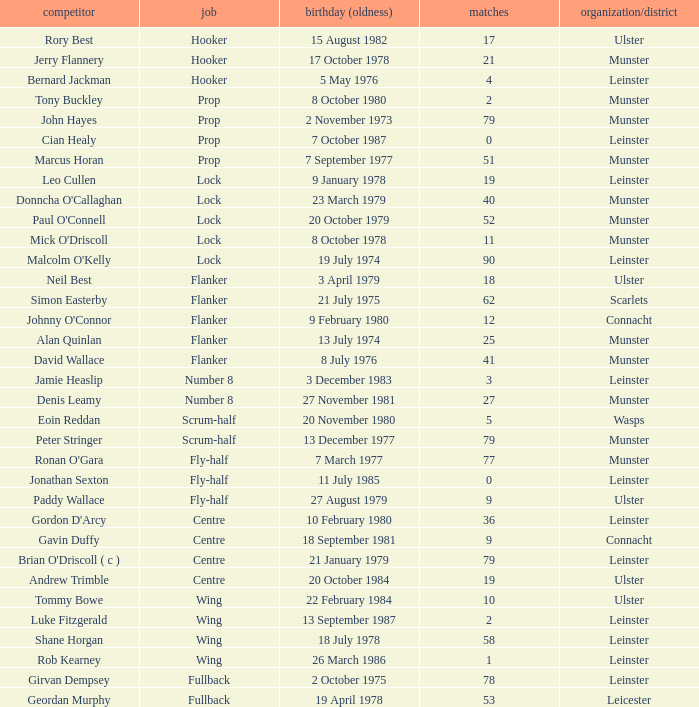How many Caps does the Club/province Munster, position of lock and Mick O'Driscoll have? 1.0. 